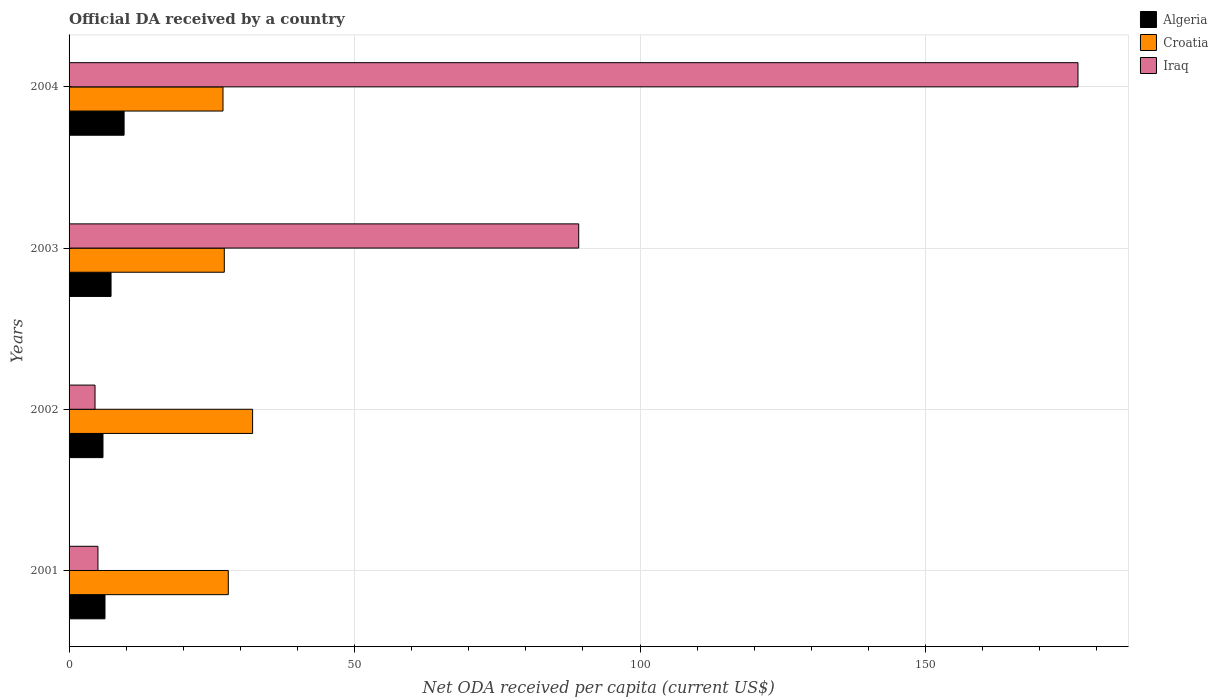How many different coloured bars are there?
Provide a succinct answer. 3. How many groups of bars are there?
Offer a very short reply. 4. Are the number of bars per tick equal to the number of legend labels?
Provide a short and direct response. Yes. How many bars are there on the 4th tick from the top?
Keep it short and to the point. 3. How many bars are there on the 4th tick from the bottom?
Ensure brevity in your answer.  3. What is the label of the 2nd group of bars from the top?
Offer a terse response. 2003. In how many cases, is the number of bars for a given year not equal to the number of legend labels?
Offer a terse response. 0. What is the ODA received in in Iraq in 2003?
Keep it short and to the point. 89.26. Across all years, what is the maximum ODA received in in Algeria?
Offer a very short reply. 9.64. Across all years, what is the minimum ODA received in in Iraq?
Your answer should be compact. 4.55. In which year was the ODA received in in Algeria minimum?
Keep it short and to the point. 2002. What is the total ODA received in in Algeria in the graph?
Your response must be concise. 29.21. What is the difference between the ODA received in in Croatia in 2002 and that in 2003?
Keep it short and to the point. 4.96. What is the difference between the ODA received in in Algeria in 2001 and the ODA received in in Iraq in 2002?
Offer a very short reply. 1.74. What is the average ODA received in in Algeria per year?
Provide a short and direct response. 7.3. In the year 2001, what is the difference between the ODA received in in Croatia and ODA received in in Iraq?
Your answer should be very brief. 22.83. In how many years, is the ODA received in in Algeria greater than 110 US$?
Ensure brevity in your answer.  0. What is the ratio of the ODA received in in Algeria in 2001 to that in 2003?
Provide a short and direct response. 0.86. Is the ODA received in in Iraq in 2002 less than that in 2004?
Your answer should be very brief. Yes. Is the difference between the ODA received in in Croatia in 2001 and 2004 greater than the difference between the ODA received in in Iraq in 2001 and 2004?
Provide a short and direct response. Yes. What is the difference between the highest and the second highest ODA received in in Croatia?
Offer a terse response. 4.26. What is the difference between the highest and the lowest ODA received in in Iraq?
Make the answer very short. 172.15. In how many years, is the ODA received in in Algeria greater than the average ODA received in in Algeria taken over all years?
Your answer should be very brief. 2. Is the sum of the ODA received in in Croatia in 2001 and 2003 greater than the maximum ODA received in in Iraq across all years?
Your answer should be very brief. No. What does the 2nd bar from the top in 2004 represents?
Your response must be concise. Croatia. What does the 3rd bar from the bottom in 2004 represents?
Your response must be concise. Iraq. How many bars are there?
Make the answer very short. 12. Are all the bars in the graph horizontal?
Your answer should be compact. Yes. What is the difference between two consecutive major ticks on the X-axis?
Offer a terse response. 50. Are the values on the major ticks of X-axis written in scientific E-notation?
Make the answer very short. No. Does the graph contain any zero values?
Keep it short and to the point. No. Does the graph contain grids?
Your response must be concise. Yes. Where does the legend appear in the graph?
Give a very brief answer. Top right. How are the legend labels stacked?
Your answer should be very brief. Vertical. What is the title of the graph?
Offer a terse response. Official DA received by a country. What is the label or title of the X-axis?
Make the answer very short. Net ODA received per capita (current US$). What is the label or title of the Y-axis?
Your response must be concise. Years. What is the Net ODA received per capita (current US$) of Algeria in 2001?
Give a very brief answer. 6.29. What is the Net ODA received per capita (current US$) of Croatia in 2001?
Ensure brevity in your answer.  27.89. What is the Net ODA received per capita (current US$) of Iraq in 2001?
Give a very brief answer. 5.06. What is the Net ODA received per capita (current US$) in Algeria in 2002?
Give a very brief answer. 5.94. What is the Net ODA received per capita (current US$) in Croatia in 2002?
Offer a very short reply. 32.14. What is the Net ODA received per capita (current US$) of Iraq in 2002?
Offer a terse response. 4.55. What is the Net ODA received per capita (current US$) of Algeria in 2003?
Ensure brevity in your answer.  7.35. What is the Net ODA received per capita (current US$) in Croatia in 2003?
Ensure brevity in your answer.  27.18. What is the Net ODA received per capita (current US$) of Iraq in 2003?
Keep it short and to the point. 89.26. What is the Net ODA received per capita (current US$) in Algeria in 2004?
Your response must be concise. 9.64. What is the Net ODA received per capita (current US$) of Croatia in 2004?
Make the answer very short. 26.96. What is the Net ODA received per capita (current US$) of Iraq in 2004?
Give a very brief answer. 176.69. Across all years, what is the maximum Net ODA received per capita (current US$) in Algeria?
Give a very brief answer. 9.64. Across all years, what is the maximum Net ODA received per capita (current US$) in Croatia?
Keep it short and to the point. 32.14. Across all years, what is the maximum Net ODA received per capita (current US$) in Iraq?
Provide a succinct answer. 176.69. Across all years, what is the minimum Net ODA received per capita (current US$) of Algeria?
Your answer should be compact. 5.94. Across all years, what is the minimum Net ODA received per capita (current US$) in Croatia?
Provide a short and direct response. 26.96. Across all years, what is the minimum Net ODA received per capita (current US$) of Iraq?
Provide a short and direct response. 4.55. What is the total Net ODA received per capita (current US$) of Algeria in the graph?
Ensure brevity in your answer.  29.21. What is the total Net ODA received per capita (current US$) of Croatia in the graph?
Your response must be concise. 114.17. What is the total Net ODA received per capita (current US$) of Iraq in the graph?
Your response must be concise. 275.55. What is the difference between the Net ODA received per capita (current US$) in Algeria in 2001 and that in 2002?
Offer a terse response. 0.35. What is the difference between the Net ODA received per capita (current US$) in Croatia in 2001 and that in 2002?
Your answer should be compact. -4.26. What is the difference between the Net ODA received per capita (current US$) in Iraq in 2001 and that in 2002?
Offer a very short reply. 0.51. What is the difference between the Net ODA received per capita (current US$) of Algeria in 2001 and that in 2003?
Your answer should be very brief. -1.06. What is the difference between the Net ODA received per capita (current US$) of Croatia in 2001 and that in 2003?
Make the answer very short. 0.7. What is the difference between the Net ODA received per capita (current US$) of Iraq in 2001 and that in 2003?
Your response must be concise. -84.2. What is the difference between the Net ODA received per capita (current US$) of Algeria in 2001 and that in 2004?
Your response must be concise. -3.35. What is the difference between the Net ODA received per capita (current US$) in Iraq in 2001 and that in 2004?
Offer a very short reply. -171.63. What is the difference between the Net ODA received per capita (current US$) of Algeria in 2002 and that in 2003?
Offer a terse response. -1.41. What is the difference between the Net ODA received per capita (current US$) of Croatia in 2002 and that in 2003?
Make the answer very short. 4.96. What is the difference between the Net ODA received per capita (current US$) of Iraq in 2002 and that in 2003?
Give a very brief answer. -84.71. What is the difference between the Net ODA received per capita (current US$) in Algeria in 2002 and that in 2004?
Make the answer very short. -3.7. What is the difference between the Net ODA received per capita (current US$) of Croatia in 2002 and that in 2004?
Offer a very short reply. 5.19. What is the difference between the Net ODA received per capita (current US$) of Iraq in 2002 and that in 2004?
Ensure brevity in your answer.  -172.15. What is the difference between the Net ODA received per capita (current US$) of Algeria in 2003 and that in 2004?
Make the answer very short. -2.28. What is the difference between the Net ODA received per capita (current US$) in Croatia in 2003 and that in 2004?
Ensure brevity in your answer.  0.23. What is the difference between the Net ODA received per capita (current US$) in Iraq in 2003 and that in 2004?
Ensure brevity in your answer.  -87.44. What is the difference between the Net ODA received per capita (current US$) in Algeria in 2001 and the Net ODA received per capita (current US$) in Croatia in 2002?
Offer a terse response. -25.85. What is the difference between the Net ODA received per capita (current US$) in Algeria in 2001 and the Net ODA received per capita (current US$) in Iraq in 2002?
Your answer should be compact. 1.74. What is the difference between the Net ODA received per capita (current US$) in Croatia in 2001 and the Net ODA received per capita (current US$) in Iraq in 2002?
Your answer should be very brief. 23.34. What is the difference between the Net ODA received per capita (current US$) in Algeria in 2001 and the Net ODA received per capita (current US$) in Croatia in 2003?
Your answer should be compact. -20.9. What is the difference between the Net ODA received per capita (current US$) of Algeria in 2001 and the Net ODA received per capita (current US$) of Iraq in 2003?
Provide a short and direct response. -82.97. What is the difference between the Net ODA received per capita (current US$) in Croatia in 2001 and the Net ODA received per capita (current US$) in Iraq in 2003?
Provide a succinct answer. -61.37. What is the difference between the Net ODA received per capita (current US$) of Algeria in 2001 and the Net ODA received per capita (current US$) of Croatia in 2004?
Give a very brief answer. -20.67. What is the difference between the Net ODA received per capita (current US$) in Algeria in 2001 and the Net ODA received per capita (current US$) in Iraq in 2004?
Your answer should be very brief. -170.4. What is the difference between the Net ODA received per capita (current US$) of Croatia in 2001 and the Net ODA received per capita (current US$) of Iraq in 2004?
Offer a very short reply. -148.81. What is the difference between the Net ODA received per capita (current US$) of Algeria in 2002 and the Net ODA received per capita (current US$) of Croatia in 2003?
Offer a terse response. -21.25. What is the difference between the Net ODA received per capita (current US$) of Algeria in 2002 and the Net ODA received per capita (current US$) of Iraq in 2003?
Your response must be concise. -83.32. What is the difference between the Net ODA received per capita (current US$) of Croatia in 2002 and the Net ODA received per capita (current US$) of Iraq in 2003?
Offer a terse response. -57.11. What is the difference between the Net ODA received per capita (current US$) in Algeria in 2002 and the Net ODA received per capita (current US$) in Croatia in 2004?
Provide a short and direct response. -21.02. What is the difference between the Net ODA received per capita (current US$) in Algeria in 2002 and the Net ODA received per capita (current US$) in Iraq in 2004?
Give a very brief answer. -170.75. What is the difference between the Net ODA received per capita (current US$) in Croatia in 2002 and the Net ODA received per capita (current US$) in Iraq in 2004?
Provide a succinct answer. -144.55. What is the difference between the Net ODA received per capita (current US$) in Algeria in 2003 and the Net ODA received per capita (current US$) in Croatia in 2004?
Your response must be concise. -19.61. What is the difference between the Net ODA received per capita (current US$) of Algeria in 2003 and the Net ODA received per capita (current US$) of Iraq in 2004?
Offer a terse response. -169.34. What is the difference between the Net ODA received per capita (current US$) in Croatia in 2003 and the Net ODA received per capita (current US$) in Iraq in 2004?
Offer a very short reply. -149.51. What is the average Net ODA received per capita (current US$) of Algeria per year?
Make the answer very short. 7.3. What is the average Net ODA received per capita (current US$) in Croatia per year?
Your response must be concise. 28.54. What is the average Net ODA received per capita (current US$) in Iraq per year?
Your answer should be very brief. 68.89. In the year 2001, what is the difference between the Net ODA received per capita (current US$) in Algeria and Net ODA received per capita (current US$) in Croatia?
Your response must be concise. -21.6. In the year 2001, what is the difference between the Net ODA received per capita (current US$) in Algeria and Net ODA received per capita (current US$) in Iraq?
Provide a succinct answer. 1.23. In the year 2001, what is the difference between the Net ODA received per capita (current US$) in Croatia and Net ODA received per capita (current US$) in Iraq?
Provide a succinct answer. 22.83. In the year 2002, what is the difference between the Net ODA received per capita (current US$) of Algeria and Net ODA received per capita (current US$) of Croatia?
Keep it short and to the point. -26.21. In the year 2002, what is the difference between the Net ODA received per capita (current US$) in Algeria and Net ODA received per capita (current US$) in Iraq?
Offer a terse response. 1.39. In the year 2002, what is the difference between the Net ODA received per capita (current US$) of Croatia and Net ODA received per capita (current US$) of Iraq?
Offer a very short reply. 27.6. In the year 2003, what is the difference between the Net ODA received per capita (current US$) of Algeria and Net ODA received per capita (current US$) of Croatia?
Offer a very short reply. -19.83. In the year 2003, what is the difference between the Net ODA received per capita (current US$) in Algeria and Net ODA received per capita (current US$) in Iraq?
Ensure brevity in your answer.  -81.9. In the year 2003, what is the difference between the Net ODA received per capita (current US$) of Croatia and Net ODA received per capita (current US$) of Iraq?
Make the answer very short. -62.07. In the year 2004, what is the difference between the Net ODA received per capita (current US$) of Algeria and Net ODA received per capita (current US$) of Croatia?
Offer a terse response. -17.32. In the year 2004, what is the difference between the Net ODA received per capita (current US$) in Algeria and Net ODA received per capita (current US$) in Iraq?
Provide a short and direct response. -167.06. In the year 2004, what is the difference between the Net ODA received per capita (current US$) in Croatia and Net ODA received per capita (current US$) in Iraq?
Offer a very short reply. -149.74. What is the ratio of the Net ODA received per capita (current US$) of Algeria in 2001 to that in 2002?
Your answer should be very brief. 1.06. What is the ratio of the Net ODA received per capita (current US$) of Croatia in 2001 to that in 2002?
Offer a terse response. 0.87. What is the ratio of the Net ODA received per capita (current US$) of Iraq in 2001 to that in 2002?
Your answer should be compact. 1.11. What is the ratio of the Net ODA received per capita (current US$) in Algeria in 2001 to that in 2003?
Your response must be concise. 0.86. What is the ratio of the Net ODA received per capita (current US$) in Croatia in 2001 to that in 2003?
Keep it short and to the point. 1.03. What is the ratio of the Net ODA received per capita (current US$) in Iraq in 2001 to that in 2003?
Make the answer very short. 0.06. What is the ratio of the Net ODA received per capita (current US$) in Algeria in 2001 to that in 2004?
Provide a succinct answer. 0.65. What is the ratio of the Net ODA received per capita (current US$) of Croatia in 2001 to that in 2004?
Keep it short and to the point. 1.03. What is the ratio of the Net ODA received per capita (current US$) in Iraq in 2001 to that in 2004?
Provide a short and direct response. 0.03. What is the ratio of the Net ODA received per capita (current US$) in Algeria in 2002 to that in 2003?
Make the answer very short. 0.81. What is the ratio of the Net ODA received per capita (current US$) in Croatia in 2002 to that in 2003?
Keep it short and to the point. 1.18. What is the ratio of the Net ODA received per capita (current US$) of Iraq in 2002 to that in 2003?
Make the answer very short. 0.05. What is the ratio of the Net ODA received per capita (current US$) of Algeria in 2002 to that in 2004?
Your answer should be very brief. 0.62. What is the ratio of the Net ODA received per capita (current US$) in Croatia in 2002 to that in 2004?
Ensure brevity in your answer.  1.19. What is the ratio of the Net ODA received per capita (current US$) in Iraq in 2002 to that in 2004?
Ensure brevity in your answer.  0.03. What is the ratio of the Net ODA received per capita (current US$) in Algeria in 2003 to that in 2004?
Offer a very short reply. 0.76. What is the ratio of the Net ODA received per capita (current US$) in Croatia in 2003 to that in 2004?
Your answer should be very brief. 1.01. What is the ratio of the Net ODA received per capita (current US$) in Iraq in 2003 to that in 2004?
Provide a short and direct response. 0.51. What is the difference between the highest and the second highest Net ODA received per capita (current US$) in Algeria?
Ensure brevity in your answer.  2.28. What is the difference between the highest and the second highest Net ODA received per capita (current US$) in Croatia?
Give a very brief answer. 4.26. What is the difference between the highest and the second highest Net ODA received per capita (current US$) of Iraq?
Provide a succinct answer. 87.44. What is the difference between the highest and the lowest Net ODA received per capita (current US$) in Algeria?
Your answer should be very brief. 3.7. What is the difference between the highest and the lowest Net ODA received per capita (current US$) of Croatia?
Give a very brief answer. 5.19. What is the difference between the highest and the lowest Net ODA received per capita (current US$) of Iraq?
Your response must be concise. 172.15. 